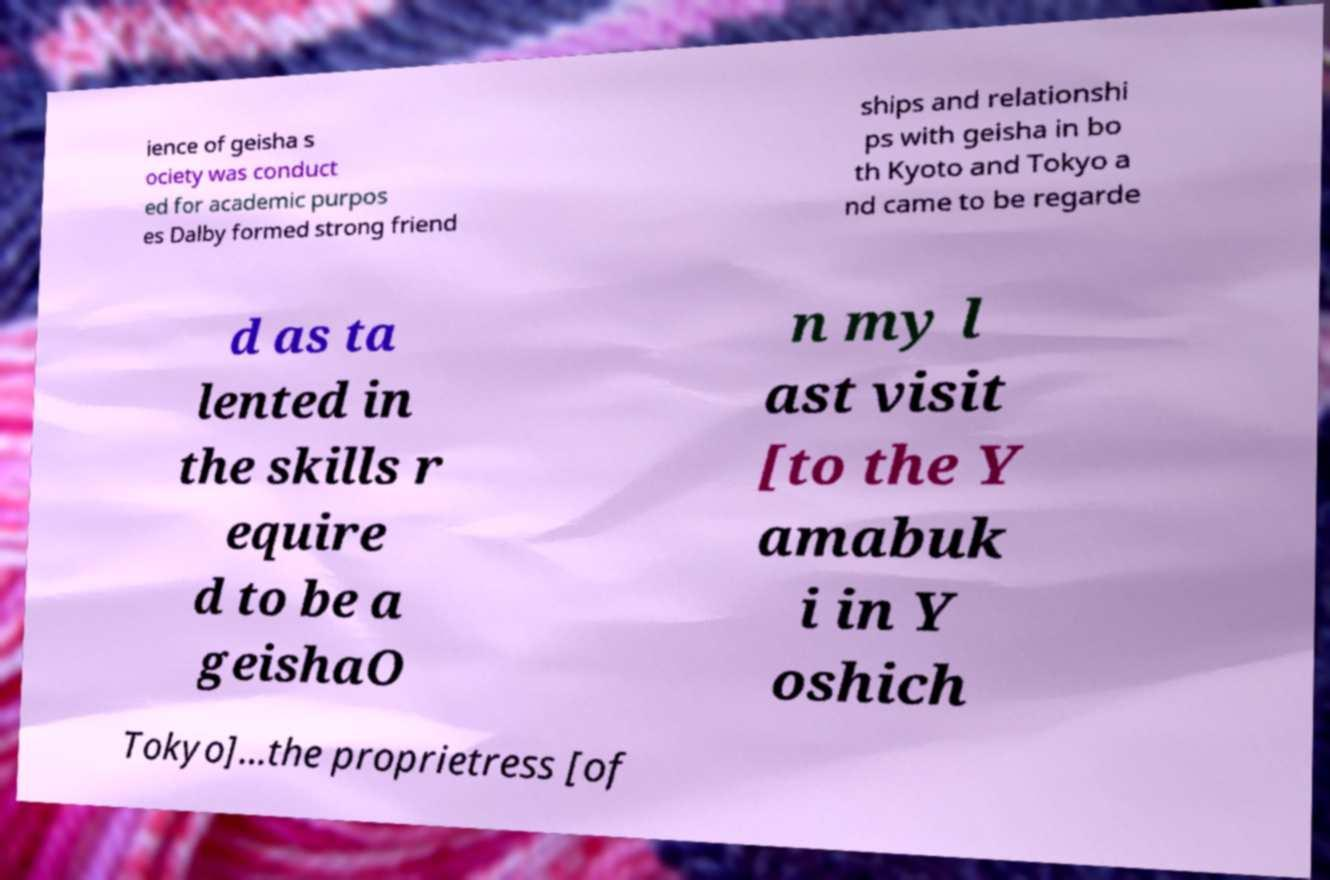What messages or text are displayed in this image? I need them in a readable, typed format. ience of geisha s ociety was conduct ed for academic purpos es Dalby formed strong friend ships and relationshi ps with geisha in bo th Kyoto and Tokyo a nd came to be regarde d as ta lented in the skills r equire d to be a geishaO n my l ast visit [to the Y amabuk i in Y oshich Tokyo]...the proprietress [of 